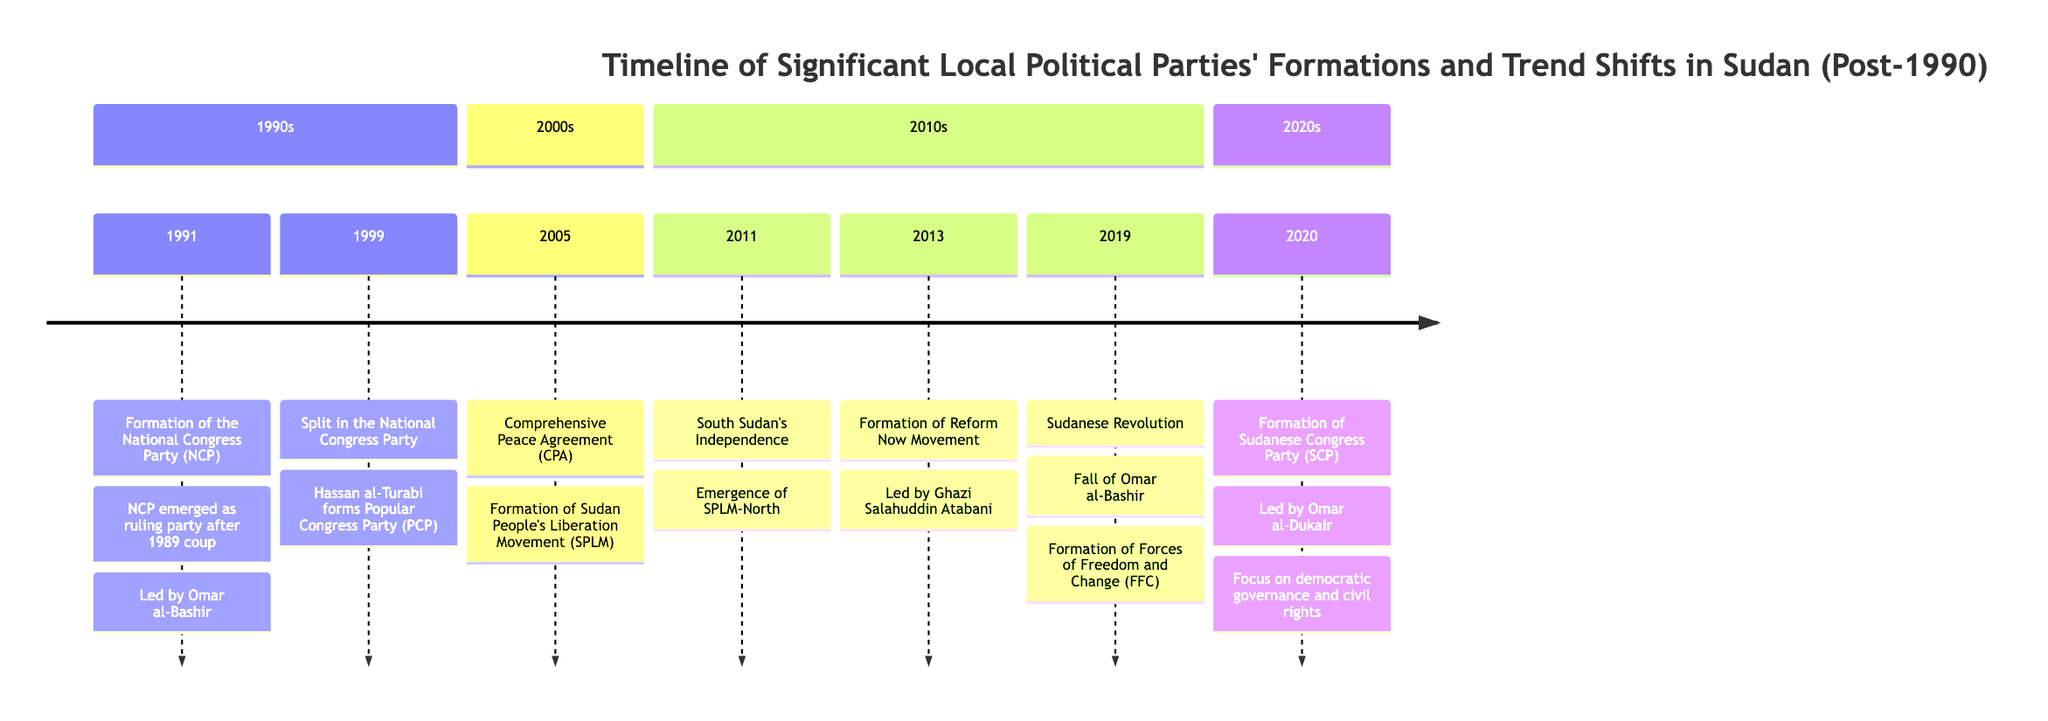What year did the National Congress Party (NCP) form? The diagram indicates that the NCP was formed in 1991. This is the year associated with the event labeled "Formation of the National Congress Party (NCP)."
Answer: 1991 Who led the Popular Congress Party (PCP) after the split in the NCP? The event in 1999 specifies that Hassan al-Turabi formed the PCP after a conflict with Omar al-Bashir. Thus, Hassan al-Turabi is the identified leader of the PCP.
Answer: Hassan al-Turabi What major agreement occurred in 2005? The timeline marks the year 2005 with the signing of the Comprehensive Peace Agreement (CPA). This is explicitly stated under the relevant event.
Answer: Comprehensive Peace Agreement (CPA) How many political parties were formed in the 2010s according to the timeline? The timeline shows three distinct political parties formed in the 2010s: SPLM-North in 2011, Reform Now Movement in 2013, and the Forces of Freedom and Change (FFC) in 2019. Counting these events gives a total of three parties.
Answer: 3 What does the Sudanese Congress Party (SCP) focus on? The details associated with the SCP indicate that it focuses on democratic governance and civil rights. The reference to these focuses is included in the section for 2020.
Answer: Democratic governance and civil rights Which party emerged as a key political entity after the Comprehensive Peace Agreement? According to the timeline, the Sudan People's Liberation Movement (SPLM) was recognized as a key entity following the CPA in 2005. Thus, SPLM is the answer.
Answer: Sudan People's Liberation Movement (SPLM) What event marked the fall of Omar al-Bashir? The timeline indicates that the fall of Omar al-Bashir occurred during the Sudanese Revolution in 2019. This explains the political shift and transition in leadership.
Answer: Sudanese Revolution In what year did the Reform Now Movement form? The timeline specifically states that the Reform Now Movement was formed in 2013, marked clearly within that year’s section.
Answer: 2013 What was the primary ideology of the NCP when it was formed? The NCP's emergence as the ruling party after the 1989 coup followed a blend of Islamic ideology with authoritarian governance, as mentioned in the details for its formation event.
Answer: Islamic ideology and authoritarian governance 